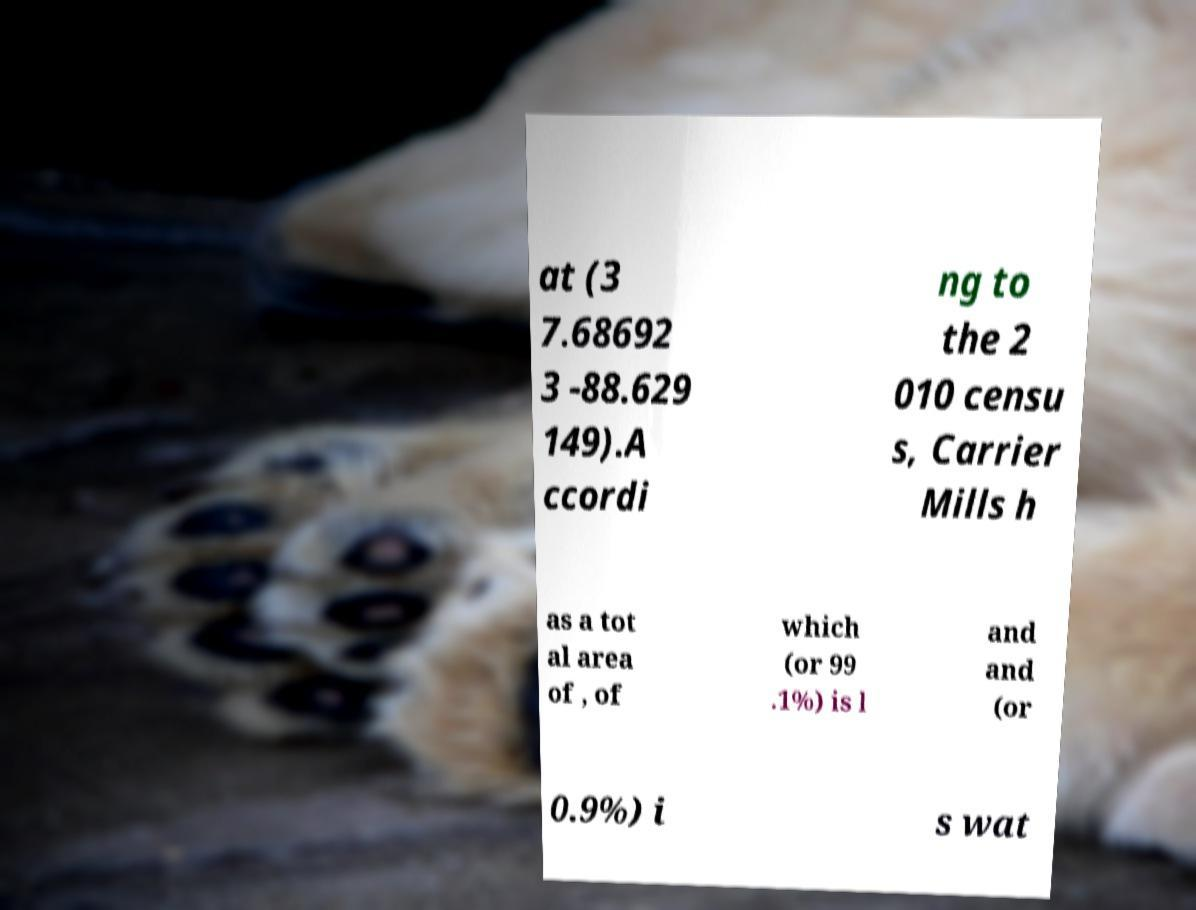Can you read and provide the text displayed in the image?This photo seems to have some interesting text. Can you extract and type it out for me? at (3 7.68692 3 -88.629 149).A ccordi ng to the 2 010 censu s, Carrier Mills h as a tot al area of , of which (or 99 .1%) is l and and (or 0.9%) i s wat 